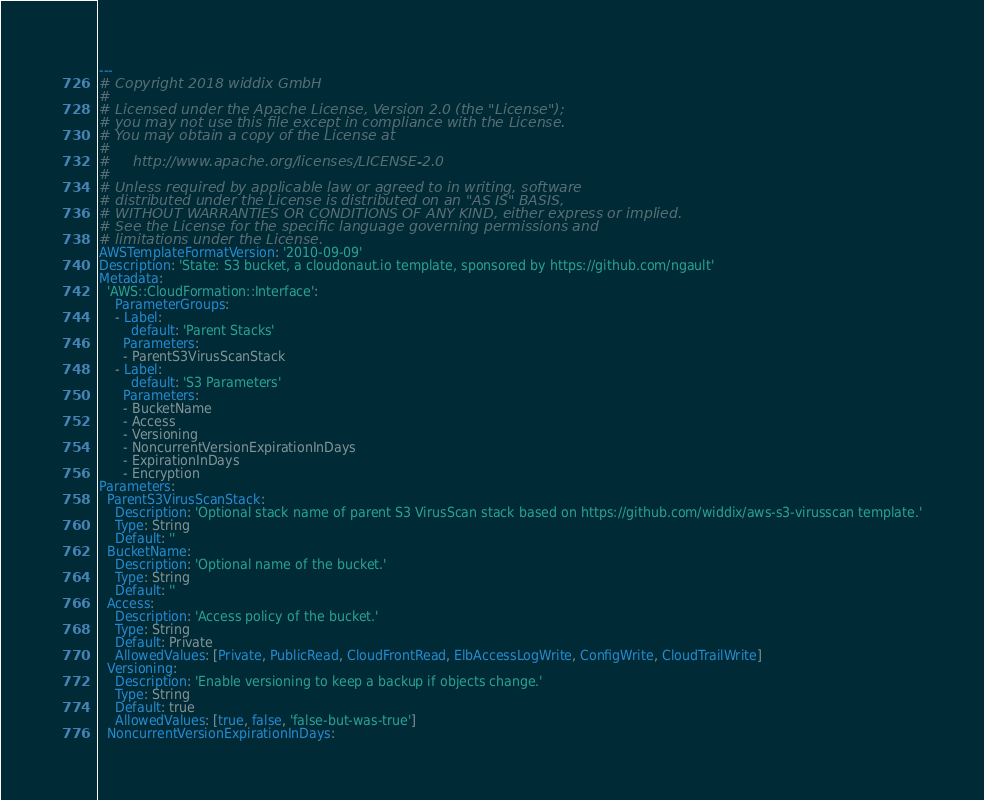Convert code to text. <code><loc_0><loc_0><loc_500><loc_500><_YAML_>---
# Copyright 2018 widdix GmbH
#
# Licensed under the Apache License, Version 2.0 (the "License");
# you may not use this file except in compliance with the License.
# You may obtain a copy of the License at
#
#     http://www.apache.org/licenses/LICENSE-2.0
#
# Unless required by applicable law or agreed to in writing, software
# distributed under the License is distributed on an "AS IS" BASIS,
# WITHOUT WARRANTIES OR CONDITIONS OF ANY KIND, either express or implied.
# See the License for the specific language governing permissions and
# limitations under the License.
AWSTemplateFormatVersion: '2010-09-09'
Description: 'State: S3 bucket, a cloudonaut.io template, sponsored by https://github.com/ngault'
Metadata:
  'AWS::CloudFormation::Interface':
    ParameterGroups:
    - Label:
        default: 'Parent Stacks'
      Parameters:
      - ParentS3VirusScanStack
    - Label:
        default: 'S3 Parameters'
      Parameters:
      - BucketName
      - Access
      - Versioning
      - NoncurrentVersionExpirationInDays
      - ExpirationInDays
      - Encryption
Parameters:
  ParentS3VirusScanStack:
    Description: 'Optional stack name of parent S3 VirusScan stack based on https://github.com/widdix/aws-s3-virusscan template.'
    Type: String
    Default: ''
  BucketName:
    Description: 'Optional name of the bucket.'
    Type: String
    Default: ''
  Access:
    Description: 'Access policy of the bucket.'
    Type: String
    Default: Private
    AllowedValues: [Private, PublicRead, CloudFrontRead, ElbAccessLogWrite, ConfigWrite, CloudTrailWrite]
  Versioning:
    Description: 'Enable versioning to keep a backup if objects change.'
    Type: String
    Default: true
    AllowedValues: [true, false, 'false-but-was-true']
  NoncurrentVersionExpirationInDays:</code> 